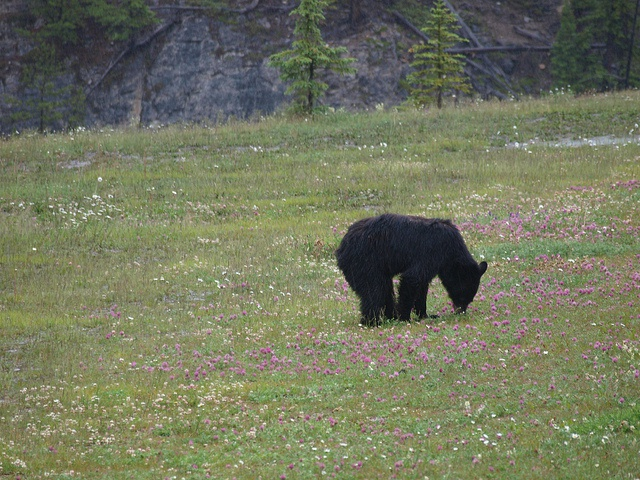Describe the objects in this image and their specific colors. I can see a bear in black, gray, and darkgreen tones in this image. 